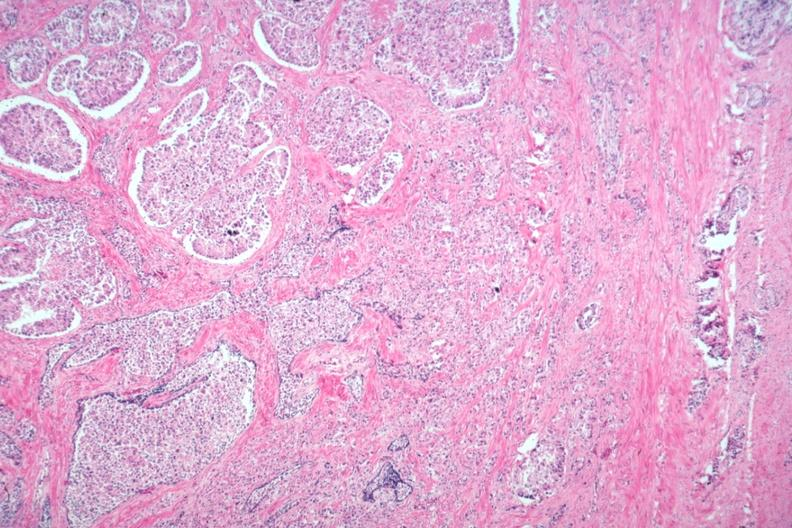s adenocarcinoma present?
Answer the question using a single word or phrase. Yes 